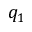<formula> <loc_0><loc_0><loc_500><loc_500>q _ { 1 }</formula> 